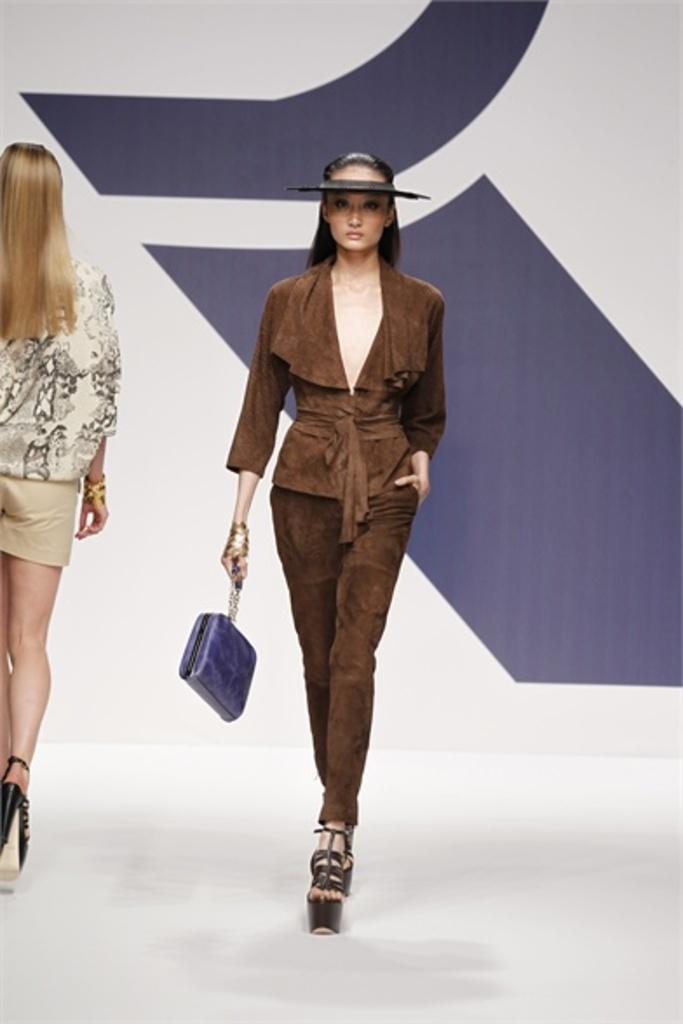What is the woman in the image holding? The woman is holding a bag in the image. What is the woman doing in the image? The woman is walking on a ramp in the image. What type of event might be taking place in the image? The scene appears to be a ramp walk, which suggests a fashion show or similar event. Are there any other people in the image? Yes, there is another woman walking in the image. What color is the orange that the woman is holding in the image? There is no orange present in the image; the woman is holding a bag. Can you tell me how many cups are visible in the image? There are no cups visible in the image. 